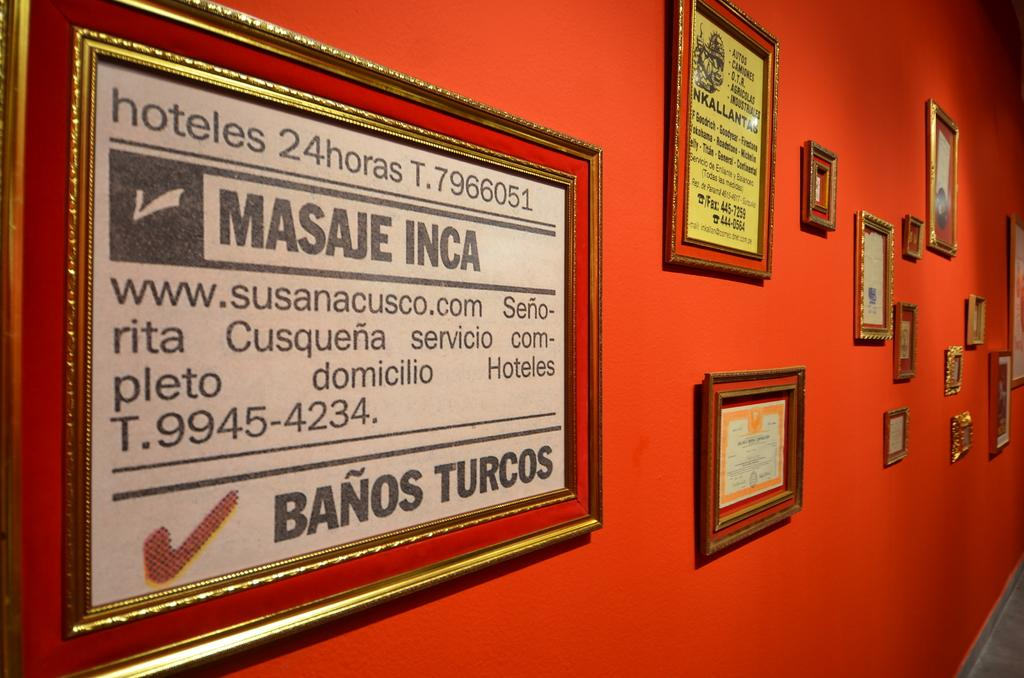<image>
Relay a brief, clear account of the picture shown. A frame hanging on an orange wall that says hoteles 24horas T.7966051 